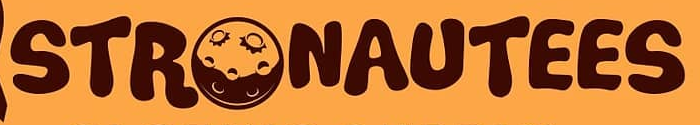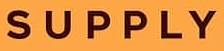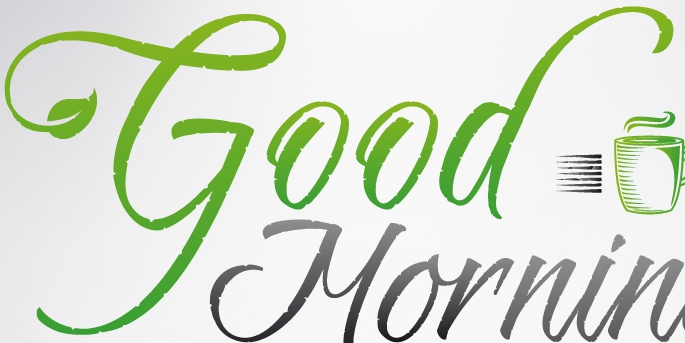Read the text content from these images in order, separated by a semicolon. STRONAUTEES; SUPPLY; Good 